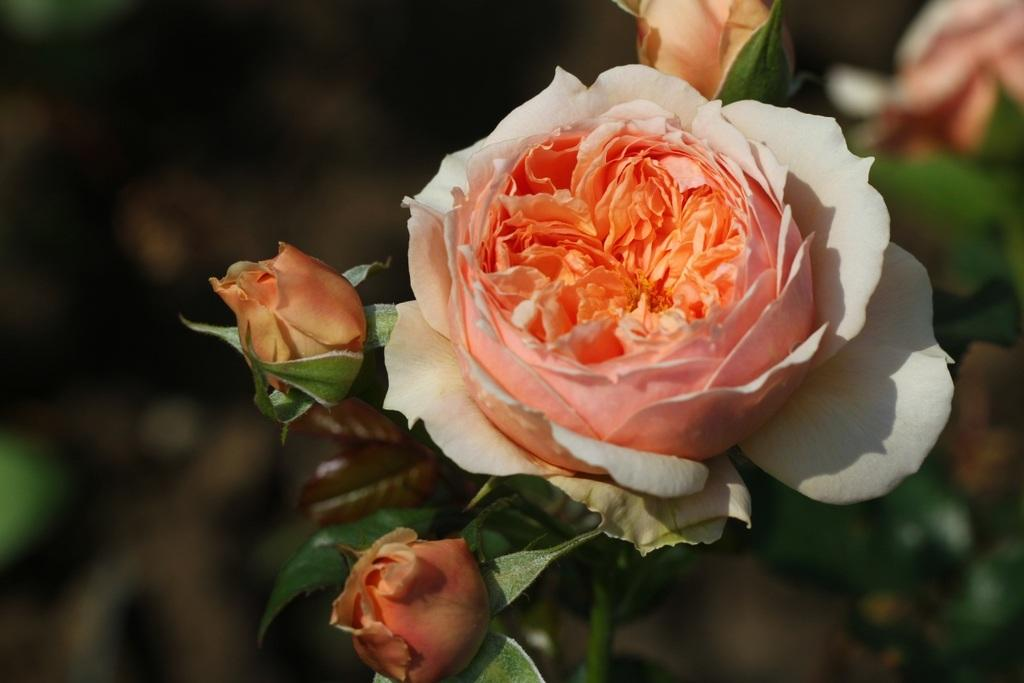What type of flower is in the image? There is a rose flower in the image. How is the rose flower connected to the rest of the plant? The rose flower is attached to a stem. What can be observed about the plant in the image? The image appears to depict a plant with flower buds, a flower, and leaves. Can you describe the background of the image? The background of the image is blurry. How many pizzas are stacked inside the jar in the image? There are no pizzas or jars present in the image; it features a rose flower with a stem and a blurry background. 